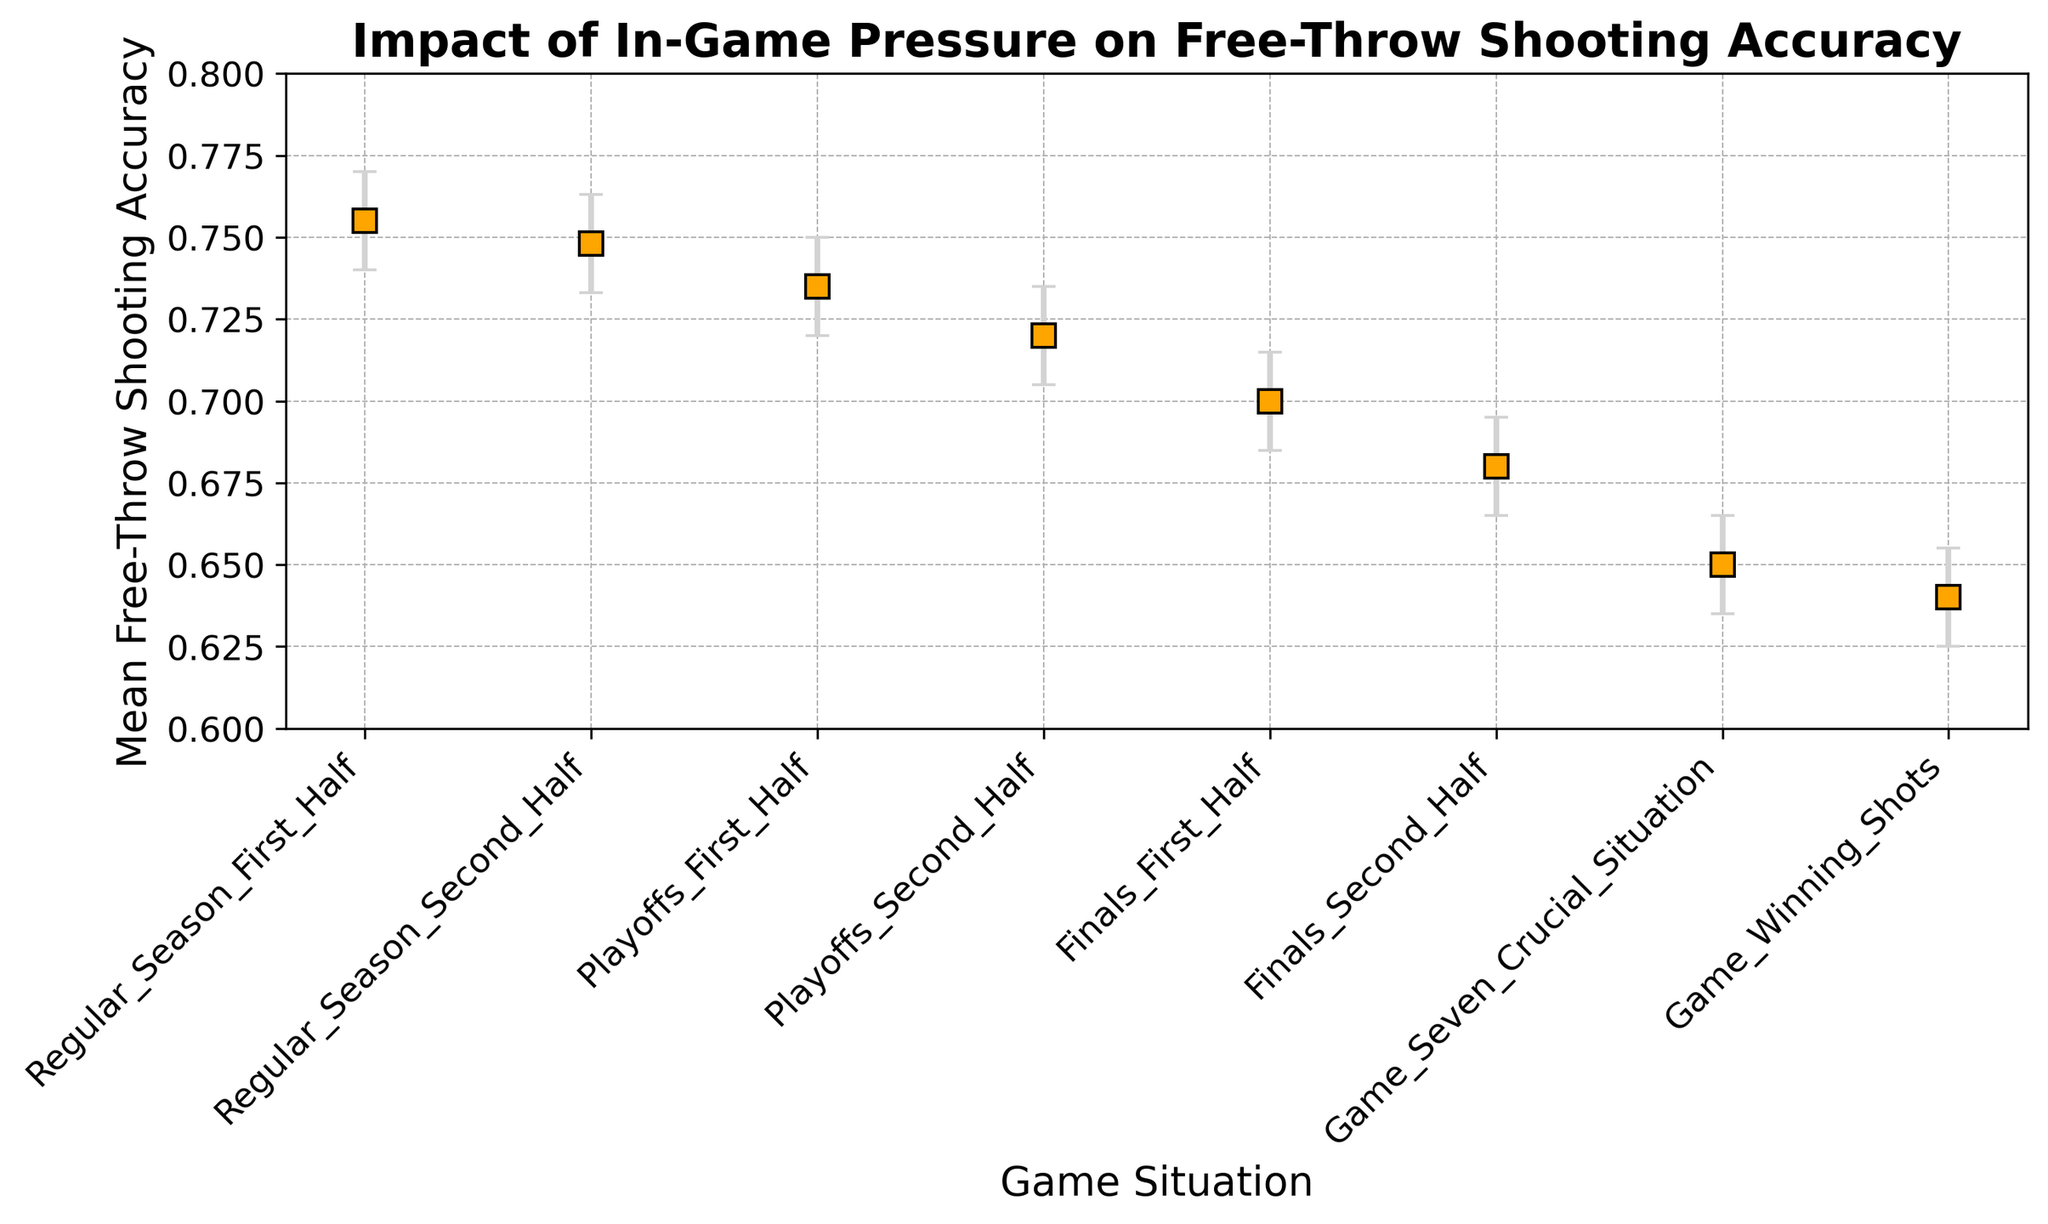What's the mean Free-Throw Shooting Accuracy during the Regular Season First Half? The figure shows the Mean Free-Throw Shooting Accuracy for different game situations. For the Regular Season First Half, the value is indicated by a marker.
Answer: 0.755 Which game situation has the lowest mean Free-Throw Shooting Accuracy? To find the lowest mean accuracy, examine all the markers and identify the one at the lowest point on the y-axis.
Answer: Game-Winning Shots Is the shooting accuracy in the Playoffs Second Half higher or lower than in the Finals First Half? Compare the markers for Playoffs Second Half and Finals First Half. The Playoffs Second Half marker is higher on the y-axis than the Finals First Half marker.
Answer: Higher What is the difference in mean Free-Throw Shooting Accuracy between Game-Winning Shots and Regular Season First Half? Subtract the mean accuracy of Game-Winning Shots from that of the Regular Season First Half: 0.755 - 0.640.
Answer: 0.115 Which game situations have higher shooting accuracy than the Finals Second Half? Look for all markers above the Finals Second Half marker on the y-axis. Identify these game situations.
Answer: Regular Season First Half, Regular Season Second Half, Playoffs First Half, Playoffs Second Half, Finals First Half Do the error bars for Playoffs First Half and Playoffs Second Half overlap? Check if the error bars (representing the confidence intervals) for both game situations intersect or touch each other. The overlapping indicates intersection.
Answer: No What’s the average mean accuracy of Regular Season First Half and Game Seven Crucial Situation? Add the mean accuracies and divide by 2: (0.755 + 0.650)/2.
Answer: 0.7025 Order the game situations from highest to lowest mean accuracy. Identify each marker's mean accuracy value, then sort them from highest to lowest.
Answer: Regular Season First Half, Regular Season Second Half, Playoffs First Half, Playoffs Second Half, Finals First Half, Finals Second Half, Game Seven Crucial Situation, Game-Winning Shots What’s the range of the confidence intervals for the Finals Second Half? Subtract the lower confidence interval from the upper confidence interval for Finals Second Half: 0.695 - 0.665.
Answer: 0.030 Which game situation has a mean accuracy closest to 0.75? Compare the mean accuracies of all game situations to 0.75 and identify the one closest to this value.
Answer: Regular Season Second Half 